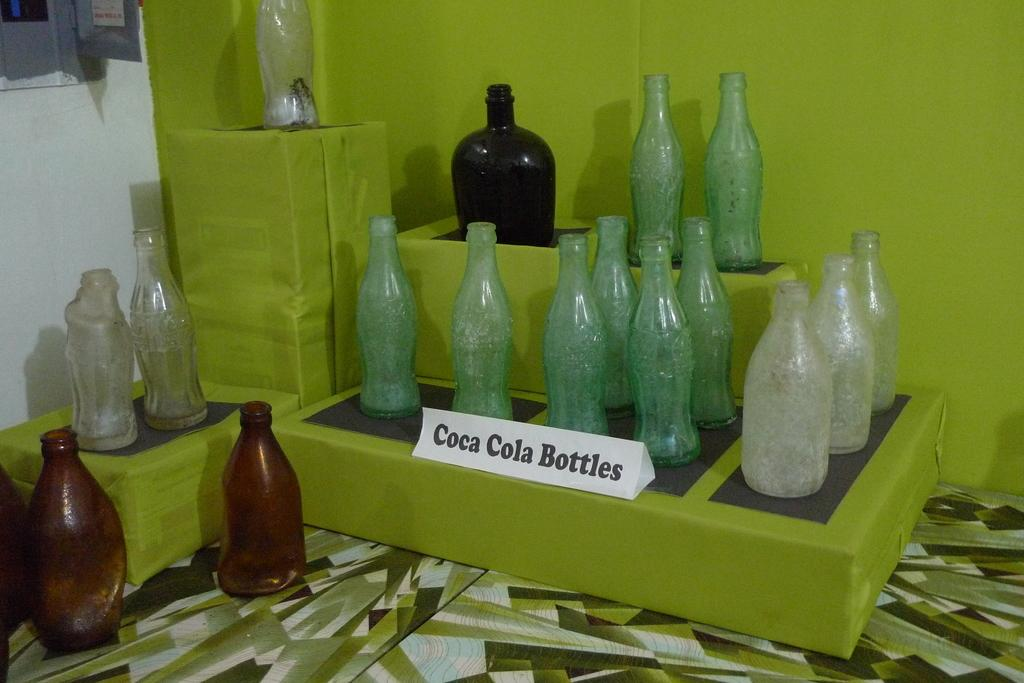<image>
Offer a succinct explanation of the picture presented. A collection of vintage glass Coca Cola Bottles with all of the labels peeled off on a platform. 